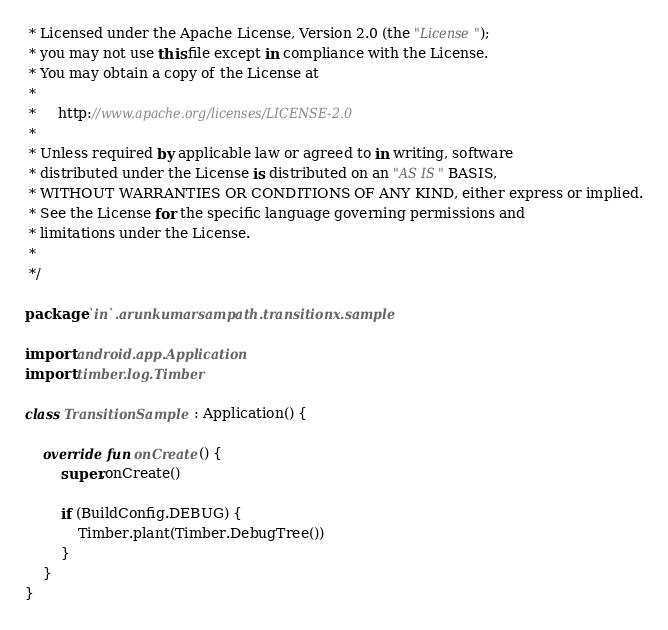Convert code to text. <code><loc_0><loc_0><loc_500><loc_500><_Kotlin_> * Licensed under the Apache License, Version 2.0 (the "License");
 * you may not use this file except in compliance with the License.
 * You may obtain a copy of the License at
 *
 *     http://www.apache.org/licenses/LICENSE-2.0
 *
 * Unless required by applicable law or agreed to in writing, software
 * distributed under the License is distributed on an "AS IS" BASIS,
 * WITHOUT WARRANTIES OR CONDITIONS OF ANY KIND, either express or implied.
 * See the License for the specific language governing permissions and
 * limitations under the License.
 *
 */

package `in`.arunkumarsampath.transitionx.sample

import android.app.Application
import timber.log.Timber

class TransitionSample : Application() {

    override fun onCreate() {
        super.onCreate()

        if (BuildConfig.DEBUG) {
            Timber.plant(Timber.DebugTree())
        }
    }
}</code> 